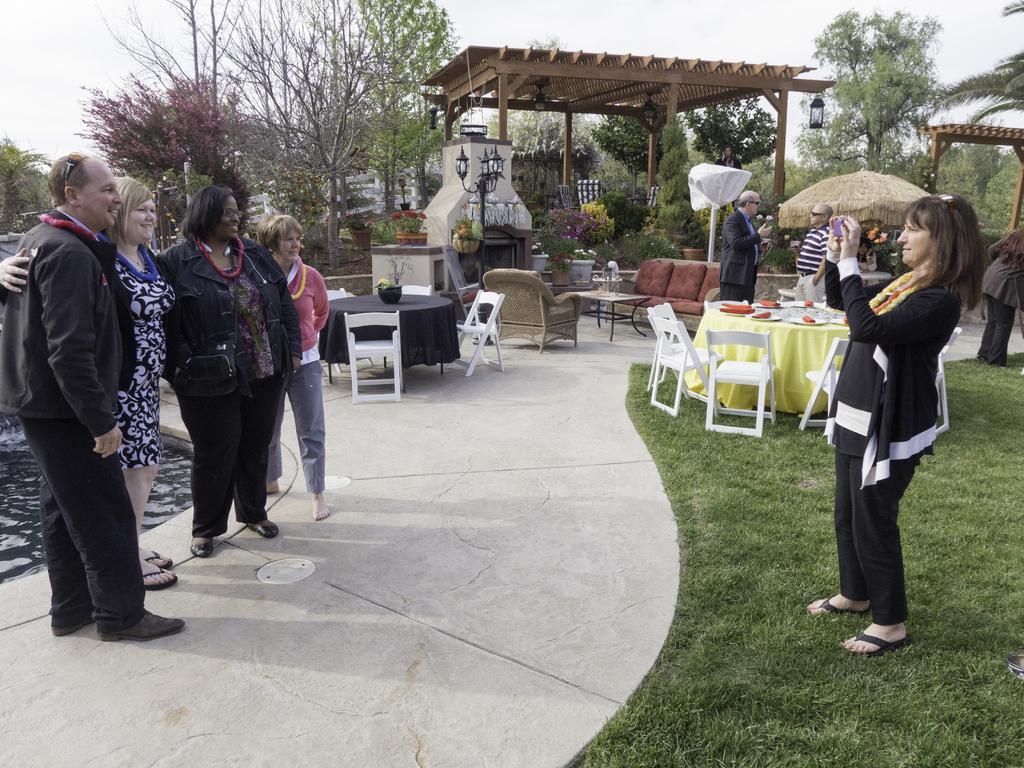Can you describe this image briefly? In this picture there are four people who are standing to the left. A woman holding a camera in her hand. There is some grass on the ground. There is a food in the plate, a green cloth on the table. There are some chairs to the right. A flower pot is visible on the table. There is a lantern , some trees ,sofa in the background. 